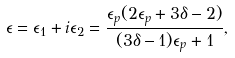Convert formula to latex. <formula><loc_0><loc_0><loc_500><loc_500>\epsilon = \epsilon _ { 1 } + i \epsilon _ { 2 } = \frac { \epsilon _ { p } ( 2 \epsilon _ { p } + 3 \delta - 2 ) } { ( 3 \delta - 1 ) \epsilon _ { p } + 1 } ,</formula> 